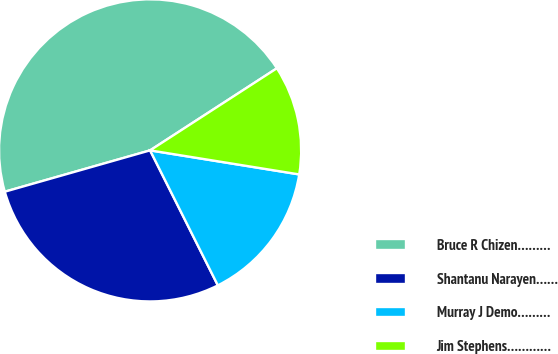Convert chart to OTSL. <chart><loc_0><loc_0><loc_500><loc_500><pie_chart><fcel>Bruce R Chizen………<fcel>Shantanu Narayen……<fcel>Murray J Demo………<fcel>Jim Stephens…………<nl><fcel>45.26%<fcel>27.99%<fcel>15.05%<fcel>11.69%<nl></chart> 